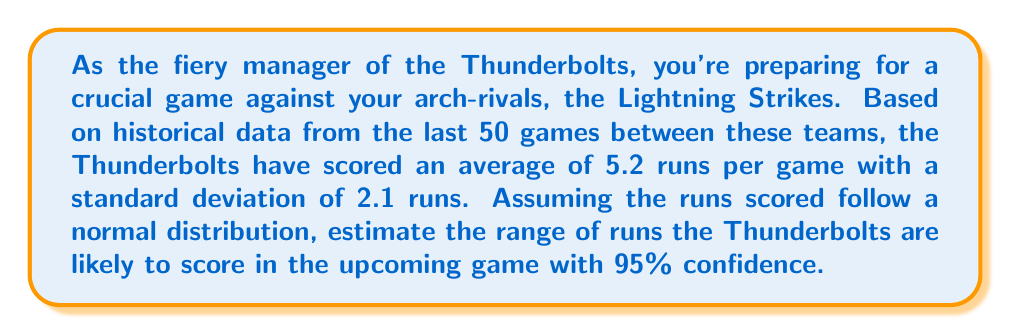Give your solution to this math problem. To solve this problem, we'll use the properties of normal distribution and the concept of confidence intervals. Here's a step-by-step approach:

1) For a normal distribution, approximately 95% of the data falls within 2 standard deviations of the mean.

2) Given:
   - Mean (μ) = 5.2 runs
   - Standard deviation (σ) = 2.1 runs
   - Confidence level = 95%

3) The formula for the 95% confidence interval is:

   $$ \text{CI} = \mu \pm (2 \times \sigma) $$

4) Substituting the values:

   $$ \text{CI} = 5.2 \pm (2 \times 2.1) $$
   $$ \text{CI} = 5.2 \pm 4.2 $$

5) Calculate the lower and upper bounds:
   
   Lower bound: $5.2 - 4.2 = 1$
   Upper bound: $5.2 + 4.2 = 9.4$

6) Since runs scored must be whole numbers, we round the lower bound up and the upper bound down to the nearest integer.

Therefore, with 95% confidence, we can estimate that the Thunderbolts will likely score between 1 and 9 runs in the upcoming game.
Answer: The Thunderbolts are likely to score between 1 and 9 runs in the upcoming game, with 95% confidence. 